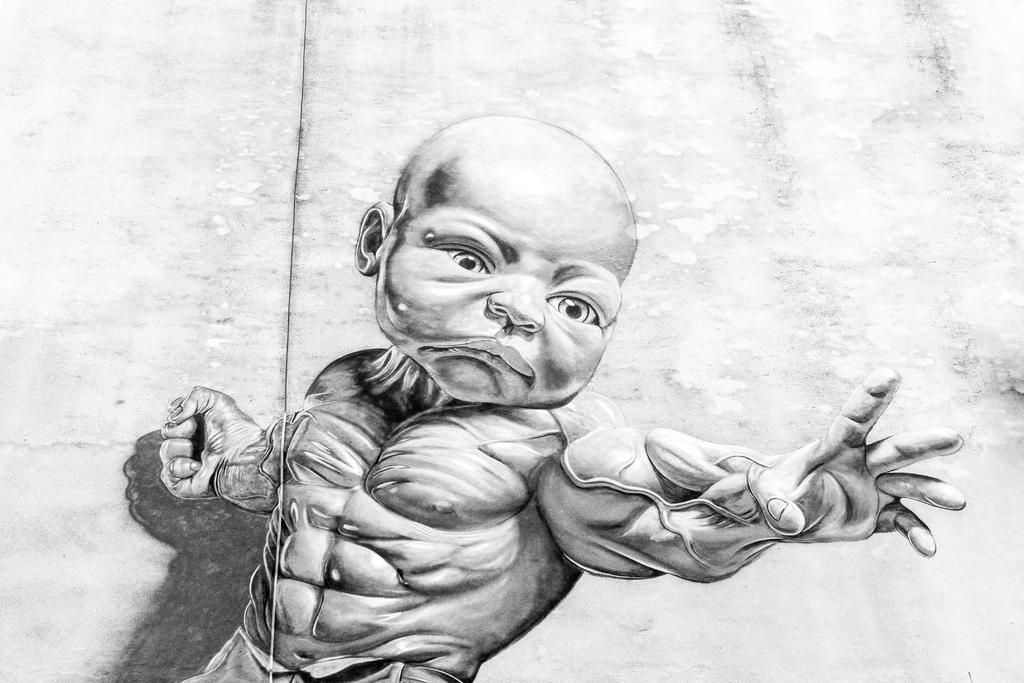Can you describe this image briefly? In this image there is a sketch of a person's body and a face of a baby is attached to it. In the background there is a wall. 